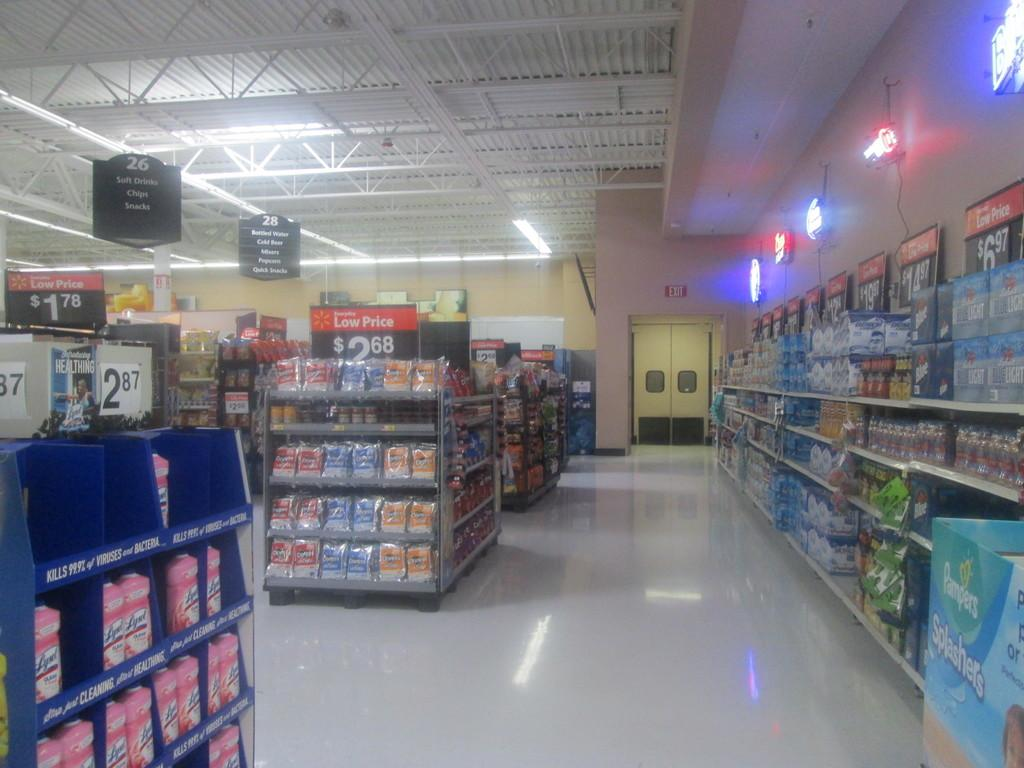What can be seen in the image that is used for storage? There are boxes and racks in the image that are used for storage. What items are stored on the racks? The racks contain packets, bottles, and other objects. What architectural features are visible in the background of the image? There are walls, a roof, name boards, lights, and rods visible in the background of the image. How many bats are hanging from the rods in the background of the image? There are no bats visible in the image; only rods, lights, and other architectural features are present. What type of clocks are displayed on the name boards in the background of the image? There are no clocks visible on the name boards in the image; only name boards and other architectural features are present. 